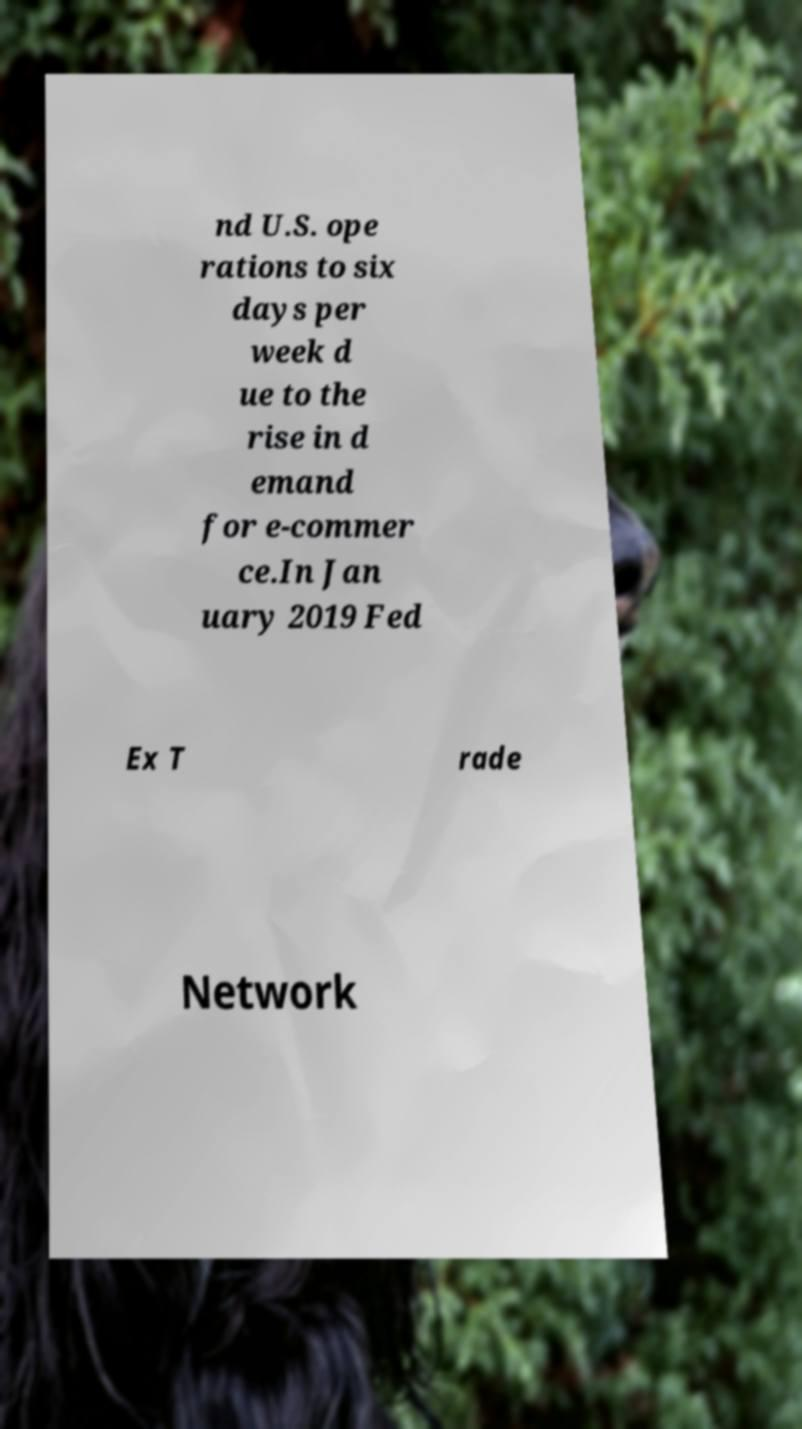Could you extract and type out the text from this image? nd U.S. ope rations to six days per week d ue to the rise in d emand for e-commer ce.In Jan uary 2019 Fed Ex T rade Network 